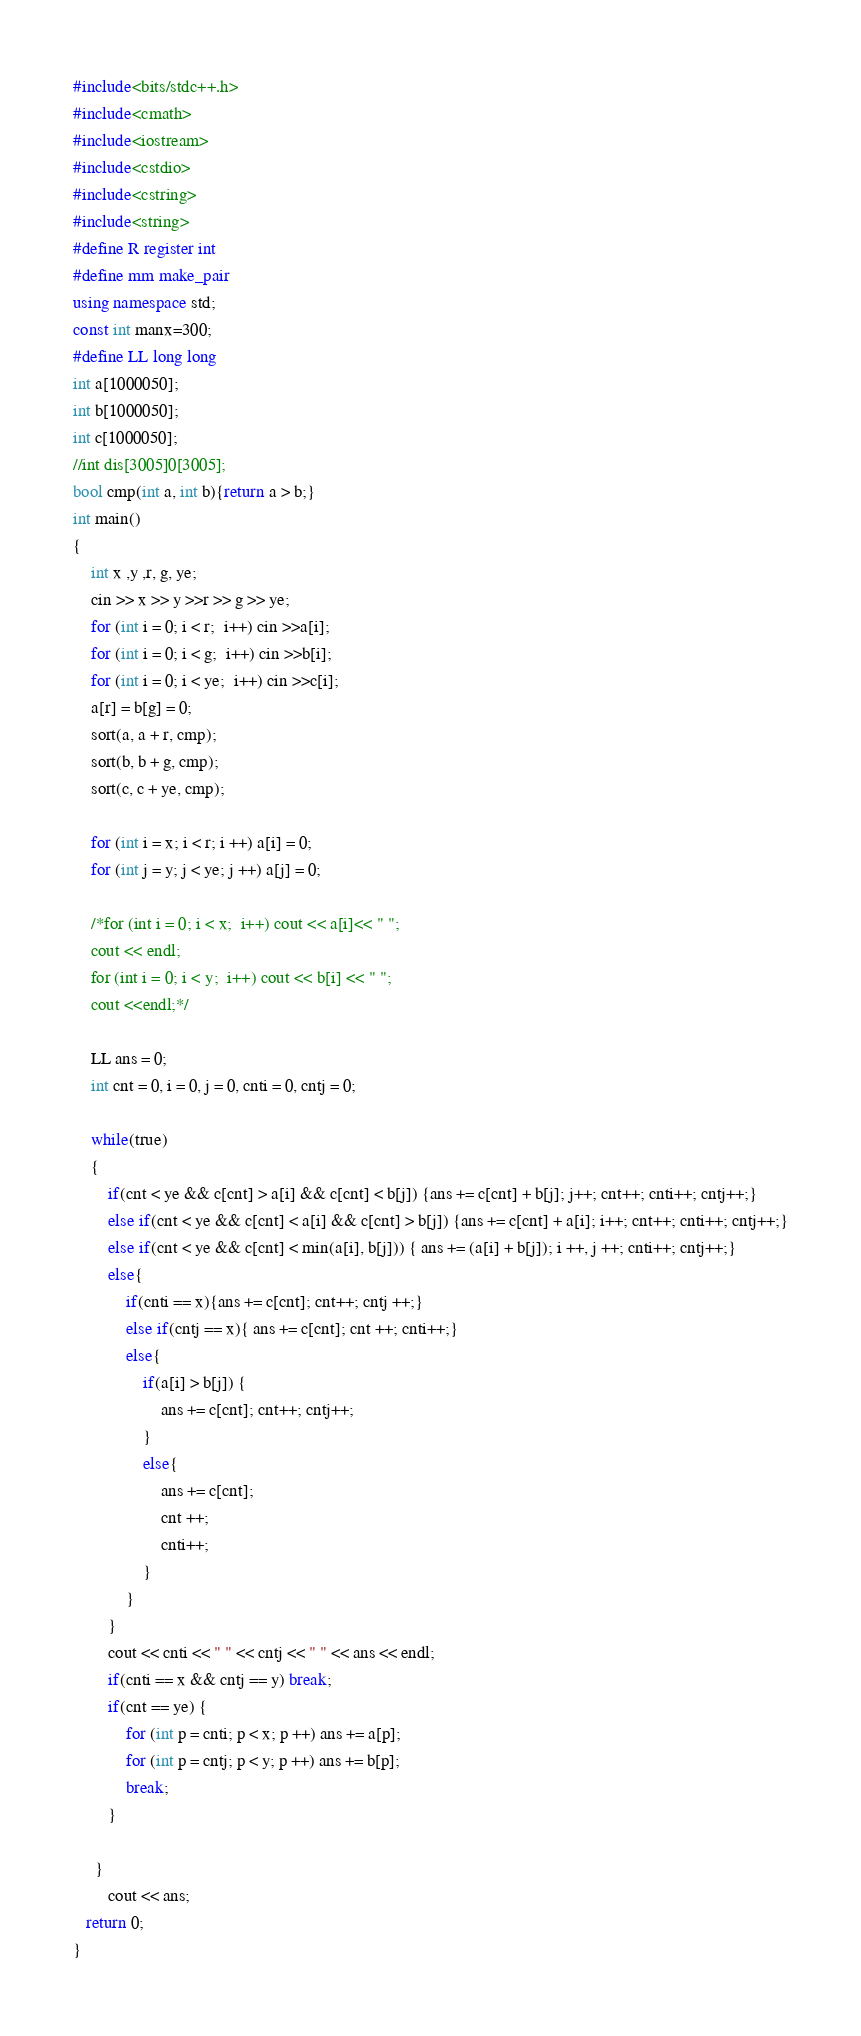<code> <loc_0><loc_0><loc_500><loc_500><_C++_>#include<bits/stdc++.h>
#include<cmath>
#include<iostream>
#include<cstdio>
#include<cstring>
#include<string>
#define R register int
#define mm make_pair
using namespace std;
const int manx=300;
#define LL long long
int a[1000050];
int b[1000050];
int c[1000050];
//int dis[3005]0[3005];
bool cmp(int a, int b){return a > b;}
int main()
{
    int x ,y ,r, g, ye;
    cin >> x >> y >>r >> g >> ye;
    for (int i = 0; i < r;  i++) cin >>a[i];
    for (int i = 0; i < g;  i++) cin >>b[i];
    for (int i = 0; i < ye;  i++) cin >>c[i];
    a[r] = b[g] = 0;
    sort(a, a + r, cmp);
    sort(b, b + g, cmp);
    sort(c, c + ye, cmp);

    for (int i = x; i < r; i ++) a[i] = 0;
    for (int j = y; j < ye; j ++) a[j] = 0;

    /*for (int i = 0; i < x;  i++) cout << a[i]<< " ";
    cout << endl;
    for (int i = 0; i < y;  i++) cout << b[i] << " ";
    cout <<endl;*/

    LL ans = 0;
    int cnt = 0, i = 0, j = 0, cnti = 0, cntj = 0;

    while(true)
    {
        if(cnt < ye && c[cnt] > a[i] && c[cnt] < b[j]) {ans += c[cnt] + b[j]; j++; cnt++; cnti++; cntj++;}
        else if(cnt < ye && c[cnt] < a[i] && c[cnt] > b[j]) {ans += c[cnt] + a[i]; i++; cnt++; cnti++; cntj++;}
        else if(cnt < ye && c[cnt] < min(a[i], b[j])) { ans += (a[i] + b[j]); i ++, j ++; cnti++; cntj++;}
        else{
            if(cnti == x){ans += c[cnt]; cnt++; cntj ++;}
            else if(cntj == x){ ans += c[cnt]; cnt ++; cnti++;}
            else{
                if(a[i] > b[j]) {
                    ans += c[cnt]; cnt++; cntj++;
                }
                else{
                    ans += c[cnt];
                    cnt ++;
                    cnti++;
                }
            }
        }
        cout << cnti << " " << cntj << " " << ans << endl;
        if(cnti == x && cntj == y) break;
        if(cnt == ye) {
            for (int p = cnti; p < x; p ++) ans += a[p];
            for (int p = cntj; p < y; p ++) ans += b[p];
            break;
        }

     }
        cout << ans;
   return 0;
}

</code> 